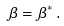Convert formula to latex. <formula><loc_0><loc_0><loc_500><loc_500>\beta = \beta ^ { * } \, .</formula> 